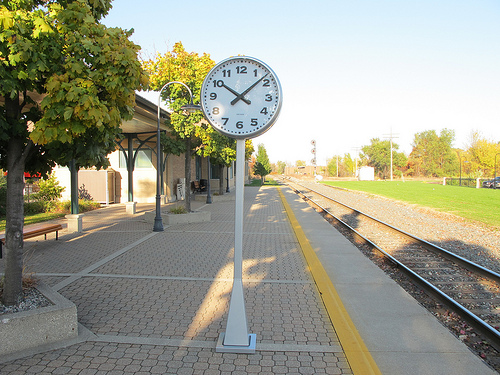<image>
Is there a clock on the train track? No. The clock is not positioned on the train track. They may be near each other, but the clock is not supported by or resting on top of the train track. Is the clock above the ground? Yes. The clock is positioned above the ground in the vertical space, higher up in the scene. 